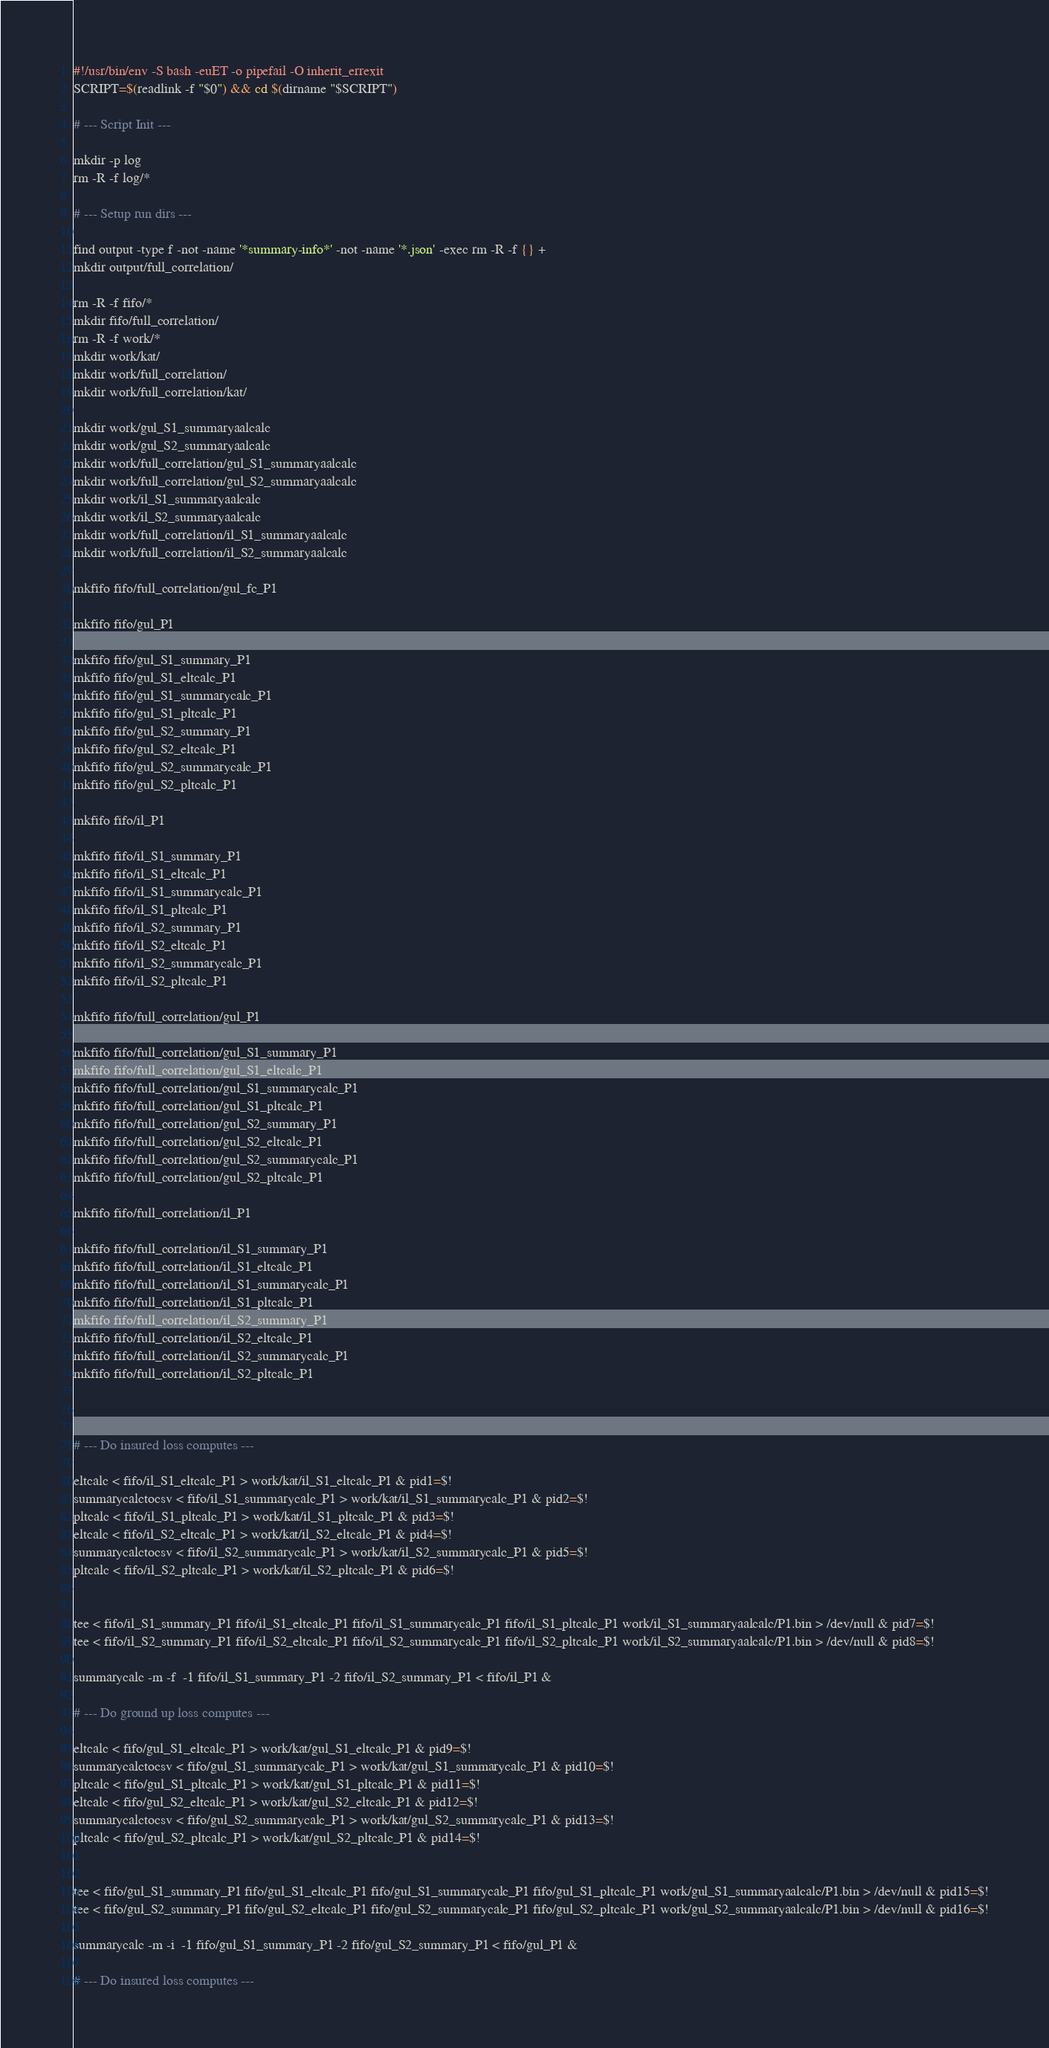Convert code to text. <code><loc_0><loc_0><loc_500><loc_500><_Bash_>#!/usr/bin/env -S bash -euET -o pipefail -O inherit_errexit
SCRIPT=$(readlink -f "$0") && cd $(dirname "$SCRIPT")

# --- Script Init ---

mkdir -p log
rm -R -f log/*

# --- Setup run dirs ---

find output -type f -not -name '*summary-info*' -not -name '*.json' -exec rm -R -f {} +
mkdir output/full_correlation/

rm -R -f fifo/*
mkdir fifo/full_correlation/
rm -R -f work/*
mkdir work/kat/
mkdir work/full_correlation/
mkdir work/full_correlation/kat/

mkdir work/gul_S1_summaryaalcalc
mkdir work/gul_S2_summaryaalcalc
mkdir work/full_correlation/gul_S1_summaryaalcalc
mkdir work/full_correlation/gul_S2_summaryaalcalc
mkdir work/il_S1_summaryaalcalc
mkdir work/il_S2_summaryaalcalc
mkdir work/full_correlation/il_S1_summaryaalcalc
mkdir work/full_correlation/il_S2_summaryaalcalc

mkfifo fifo/full_correlation/gul_fc_P1

mkfifo fifo/gul_P1

mkfifo fifo/gul_S1_summary_P1
mkfifo fifo/gul_S1_eltcalc_P1
mkfifo fifo/gul_S1_summarycalc_P1
mkfifo fifo/gul_S1_pltcalc_P1
mkfifo fifo/gul_S2_summary_P1
mkfifo fifo/gul_S2_eltcalc_P1
mkfifo fifo/gul_S2_summarycalc_P1
mkfifo fifo/gul_S2_pltcalc_P1

mkfifo fifo/il_P1

mkfifo fifo/il_S1_summary_P1
mkfifo fifo/il_S1_eltcalc_P1
mkfifo fifo/il_S1_summarycalc_P1
mkfifo fifo/il_S1_pltcalc_P1
mkfifo fifo/il_S2_summary_P1
mkfifo fifo/il_S2_eltcalc_P1
mkfifo fifo/il_S2_summarycalc_P1
mkfifo fifo/il_S2_pltcalc_P1

mkfifo fifo/full_correlation/gul_P1

mkfifo fifo/full_correlation/gul_S1_summary_P1
mkfifo fifo/full_correlation/gul_S1_eltcalc_P1
mkfifo fifo/full_correlation/gul_S1_summarycalc_P1
mkfifo fifo/full_correlation/gul_S1_pltcalc_P1
mkfifo fifo/full_correlation/gul_S2_summary_P1
mkfifo fifo/full_correlation/gul_S2_eltcalc_P1
mkfifo fifo/full_correlation/gul_S2_summarycalc_P1
mkfifo fifo/full_correlation/gul_S2_pltcalc_P1

mkfifo fifo/full_correlation/il_P1

mkfifo fifo/full_correlation/il_S1_summary_P1
mkfifo fifo/full_correlation/il_S1_eltcalc_P1
mkfifo fifo/full_correlation/il_S1_summarycalc_P1
mkfifo fifo/full_correlation/il_S1_pltcalc_P1
mkfifo fifo/full_correlation/il_S2_summary_P1
mkfifo fifo/full_correlation/il_S2_eltcalc_P1
mkfifo fifo/full_correlation/il_S2_summarycalc_P1
mkfifo fifo/full_correlation/il_S2_pltcalc_P1



# --- Do insured loss computes ---

eltcalc < fifo/il_S1_eltcalc_P1 > work/kat/il_S1_eltcalc_P1 & pid1=$!
summarycalctocsv < fifo/il_S1_summarycalc_P1 > work/kat/il_S1_summarycalc_P1 & pid2=$!
pltcalc < fifo/il_S1_pltcalc_P1 > work/kat/il_S1_pltcalc_P1 & pid3=$!
eltcalc < fifo/il_S2_eltcalc_P1 > work/kat/il_S2_eltcalc_P1 & pid4=$!
summarycalctocsv < fifo/il_S2_summarycalc_P1 > work/kat/il_S2_summarycalc_P1 & pid5=$!
pltcalc < fifo/il_S2_pltcalc_P1 > work/kat/il_S2_pltcalc_P1 & pid6=$!


tee < fifo/il_S1_summary_P1 fifo/il_S1_eltcalc_P1 fifo/il_S1_summarycalc_P1 fifo/il_S1_pltcalc_P1 work/il_S1_summaryaalcalc/P1.bin > /dev/null & pid7=$!
tee < fifo/il_S2_summary_P1 fifo/il_S2_eltcalc_P1 fifo/il_S2_summarycalc_P1 fifo/il_S2_pltcalc_P1 work/il_S2_summaryaalcalc/P1.bin > /dev/null & pid8=$!

summarycalc -m -f  -1 fifo/il_S1_summary_P1 -2 fifo/il_S2_summary_P1 < fifo/il_P1 &

# --- Do ground up loss computes ---

eltcalc < fifo/gul_S1_eltcalc_P1 > work/kat/gul_S1_eltcalc_P1 & pid9=$!
summarycalctocsv < fifo/gul_S1_summarycalc_P1 > work/kat/gul_S1_summarycalc_P1 & pid10=$!
pltcalc < fifo/gul_S1_pltcalc_P1 > work/kat/gul_S1_pltcalc_P1 & pid11=$!
eltcalc < fifo/gul_S2_eltcalc_P1 > work/kat/gul_S2_eltcalc_P1 & pid12=$!
summarycalctocsv < fifo/gul_S2_summarycalc_P1 > work/kat/gul_S2_summarycalc_P1 & pid13=$!
pltcalc < fifo/gul_S2_pltcalc_P1 > work/kat/gul_S2_pltcalc_P1 & pid14=$!


tee < fifo/gul_S1_summary_P1 fifo/gul_S1_eltcalc_P1 fifo/gul_S1_summarycalc_P1 fifo/gul_S1_pltcalc_P1 work/gul_S1_summaryaalcalc/P1.bin > /dev/null & pid15=$!
tee < fifo/gul_S2_summary_P1 fifo/gul_S2_eltcalc_P1 fifo/gul_S2_summarycalc_P1 fifo/gul_S2_pltcalc_P1 work/gul_S2_summaryaalcalc/P1.bin > /dev/null & pid16=$!

summarycalc -m -i  -1 fifo/gul_S1_summary_P1 -2 fifo/gul_S2_summary_P1 < fifo/gul_P1 &

# --- Do insured loss computes ---
</code> 